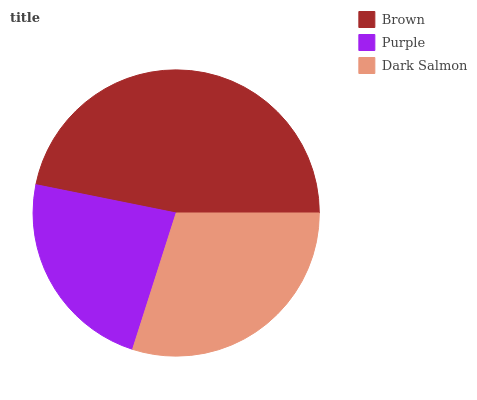Is Purple the minimum?
Answer yes or no. Yes. Is Brown the maximum?
Answer yes or no. Yes. Is Dark Salmon the minimum?
Answer yes or no. No. Is Dark Salmon the maximum?
Answer yes or no. No. Is Dark Salmon greater than Purple?
Answer yes or no. Yes. Is Purple less than Dark Salmon?
Answer yes or no. Yes. Is Purple greater than Dark Salmon?
Answer yes or no. No. Is Dark Salmon less than Purple?
Answer yes or no. No. Is Dark Salmon the high median?
Answer yes or no. Yes. Is Dark Salmon the low median?
Answer yes or no. Yes. Is Purple the high median?
Answer yes or no. No. Is Brown the low median?
Answer yes or no. No. 